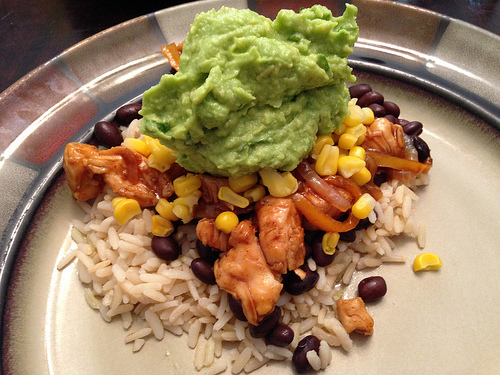<image>
Can you confirm if the chicken is under the rice? No. The chicken is not positioned under the rice. The vertical relationship between these objects is different. Is the plate behind the chicken? No. The plate is not behind the chicken. From this viewpoint, the plate appears to be positioned elsewhere in the scene. 